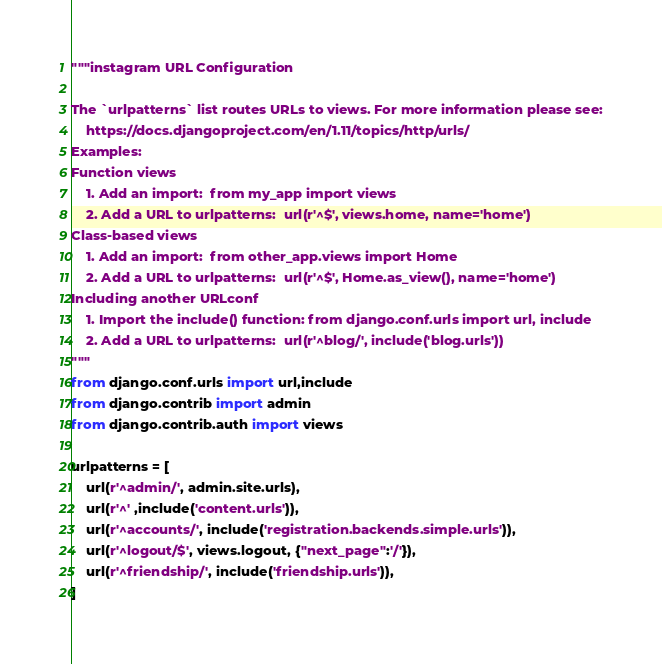<code> <loc_0><loc_0><loc_500><loc_500><_Python_>"""instagram URL Configuration

The `urlpatterns` list routes URLs to views. For more information please see:
    https://docs.djangoproject.com/en/1.11/topics/http/urls/
Examples:
Function views
    1. Add an import:  from my_app import views
    2. Add a URL to urlpatterns:  url(r'^$', views.home, name='home')
Class-based views
    1. Add an import:  from other_app.views import Home
    2. Add a URL to urlpatterns:  url(r'^$', Home.as_view(), name='home')
Including another URLconf
    1. Import the include() function: from django.conf.urls import url, include
    2. Add a URL to urlpatterns:  url(r'^blog/', include('blog.urls'))
"""
from django.conf.urls import url,include
from django.contrib import admin
from django.contrib.auth import views

urlpatterns = [
    url(r'^admin/', admin.site.urls),
    url(r'^' ,include('content.urls')),
    url(r'^accounts/', include('registration.backends.simple.urls')),
    url(r'^logout/$', views.logout, {"next_page":'/'}),
    url(r'^friendship/', include('friendship.urls')),
]</code> 